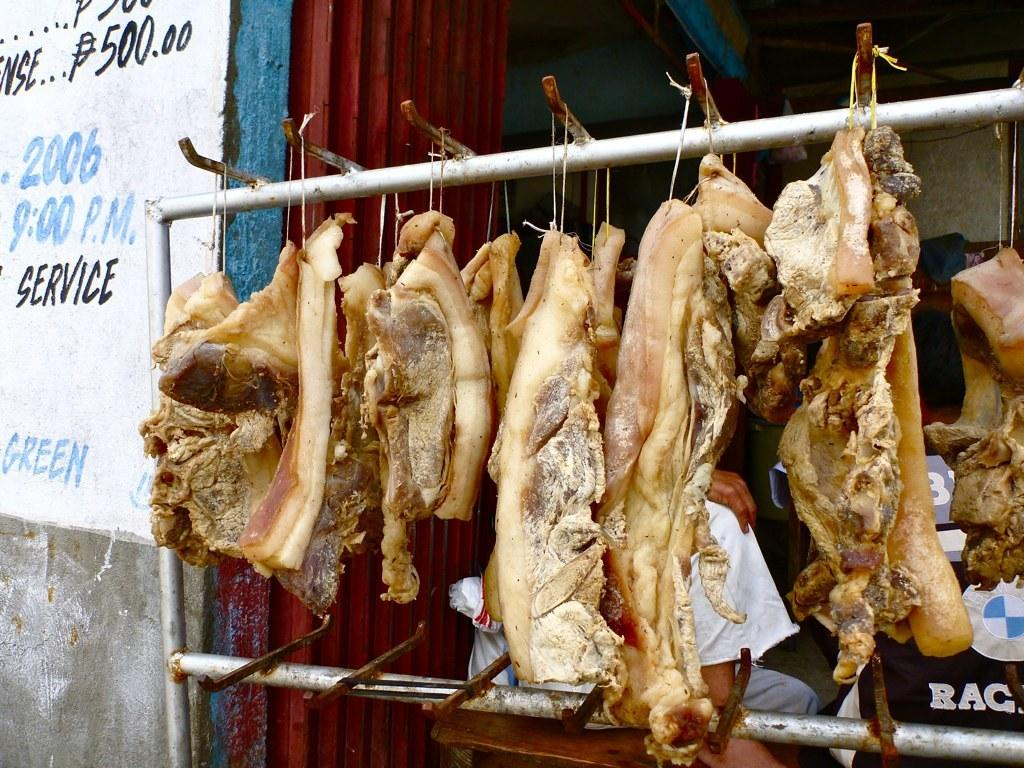What is hanging from the stand in the image? There is meat hanging from a stand in the image. Can you describe the person in the image? There is a person standing behind the meat stand in the image. What is on the left side of the image? There is a wall with text on the left side of the image. How many chances does the person have to fill the basin with water in the image? There is no basin or water present in the image, so the question cannot be answered. 